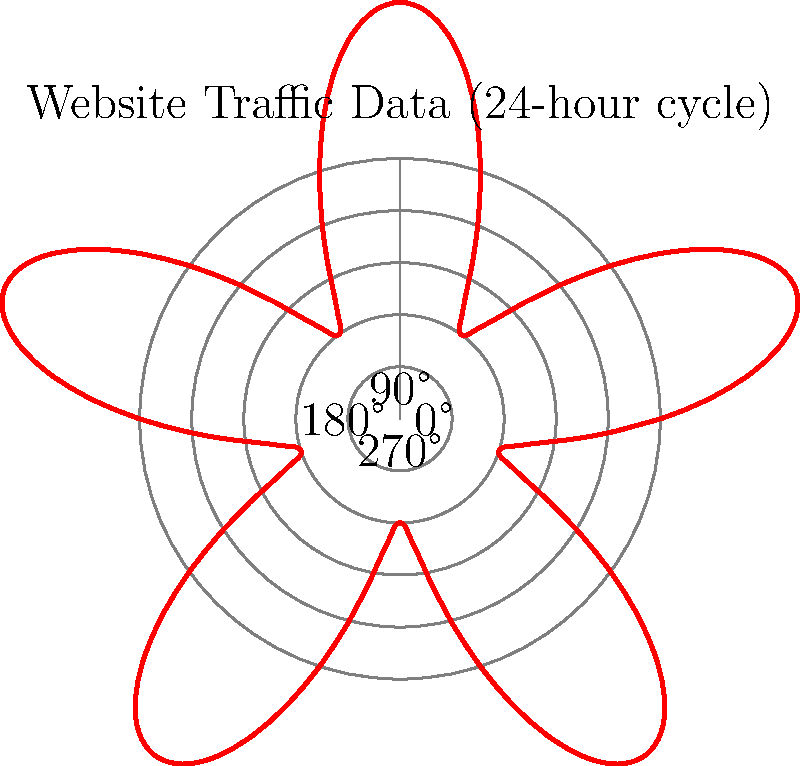Given the polar coordinate graph representing website traffic data over a 24-hour cycle, what is the approximate number of peak traffic periods observed, and at which hour does the highest traffic occur? To answer this question, we need to analyze the given polar coordinate graph:

1. The graph represents website traffic data over a 24-hour cycle, where the angle corresponds to the time of day (0° = midnight, 90° = 6 AM, 180° = noon, 270° = 6 PM).

2. The distance from the center represents the volume of traffic.

3. To count the number of peak traffic periods:
   - Look for local maxima (points farthest from the center) in the red curve.
   - Count these peaks as you move around the circle.
   - There are approximately 5 distinct peaks visible.

4. To determine the hour with the highest traffic:
   - Identify the global maximum (the point farthest from the center overall).
   - This point appears to be between 90° and 180°, closer to 180°.
   - 180° corresponds to noon (12 PM).
   - The highest peak seems to occur around 150°, which is equivalent to 10 AM.

5. Converting angle to time:
   $\frac{150°}{360°} \times 24 \text{ hours} = 10 \text{ hours}$ (from midnight)

Therefore, there are approximately 5 peak traffic periods, with the highest traffic occurring around 10 AM.
Answer: 5 peaks; 10 AM 